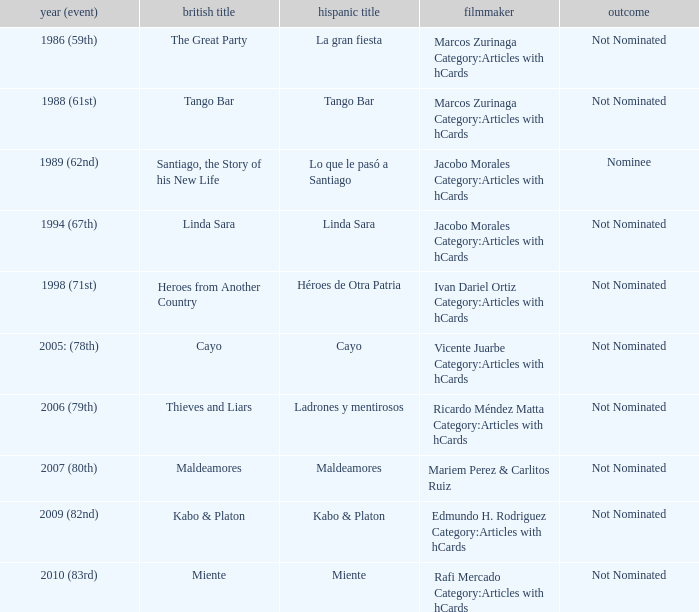What was the English title fo the film that was a nominee? Santiago, the Story of his New Life. 